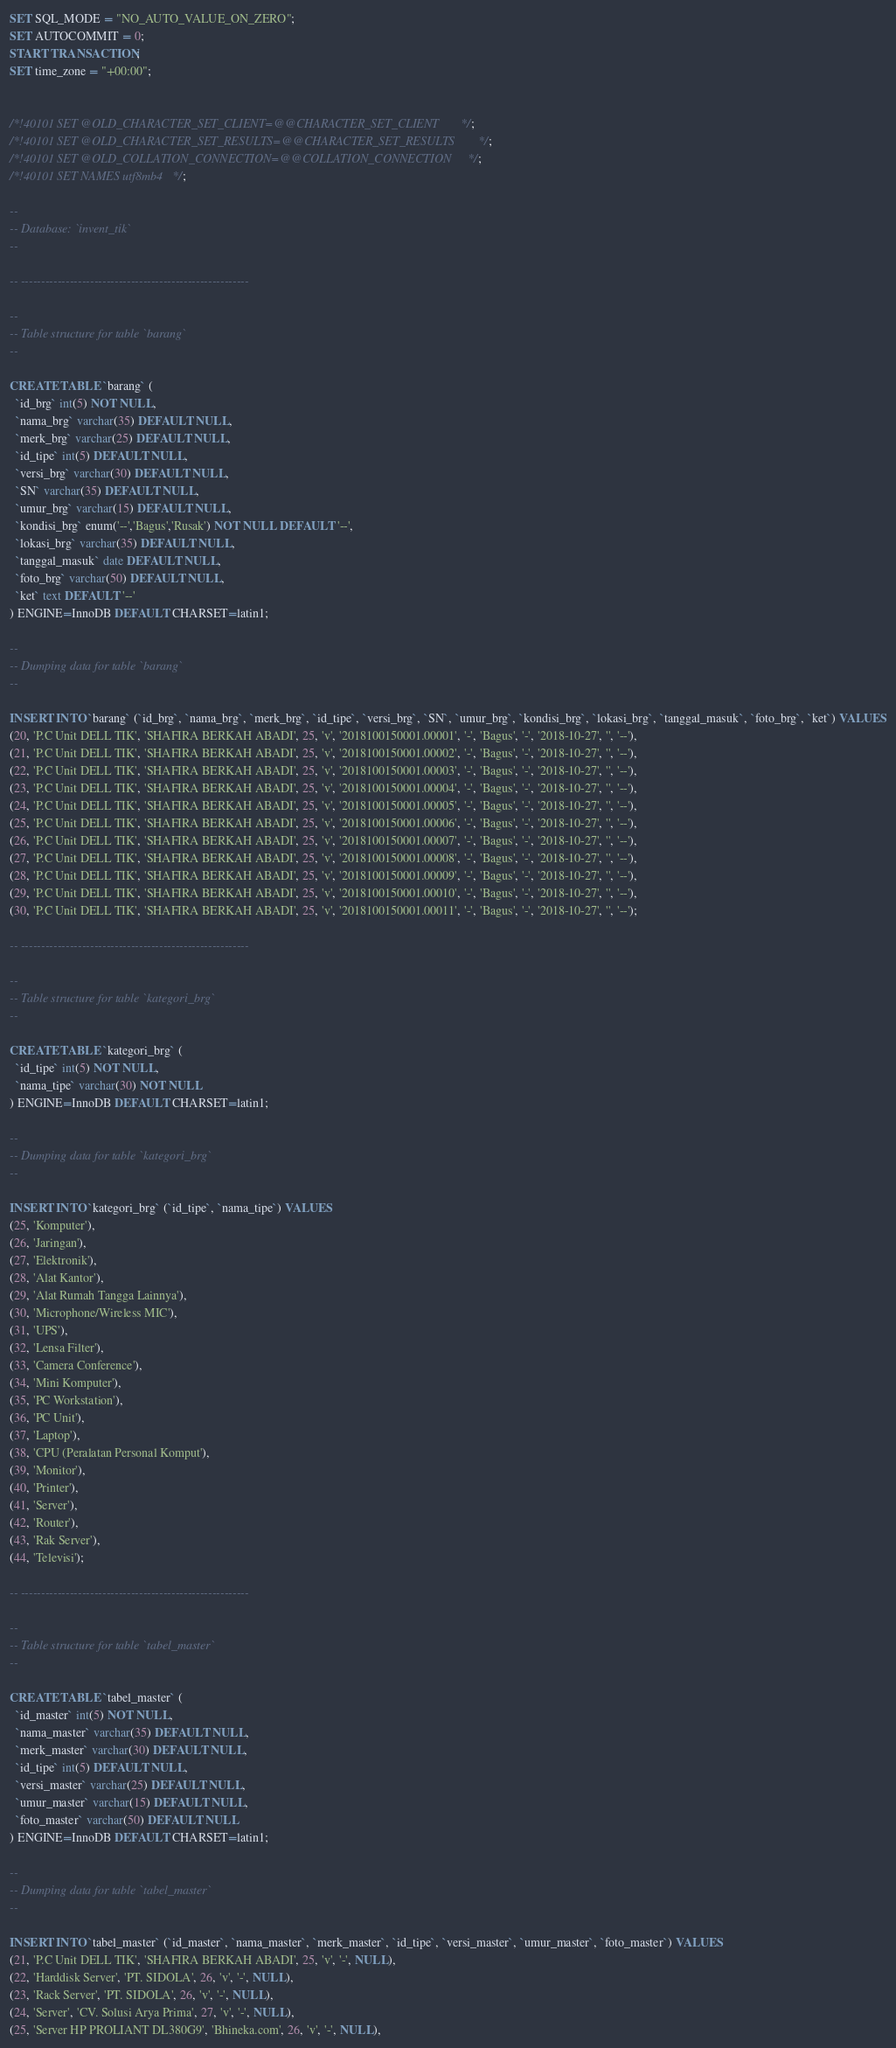Convert code to text. <code><loc_0><loc_0><loc_500><loc_500><_SQL_>SET SQL_MODE = "NO_AUTO_VALUE_ON_ZERO";
SET AUTOCOMMIT = 0;
START TRANSACTION;
SET time_zone = "+00:00";


/*!40101 SET @OLD_CHARACTER_SET_CLIENT=@@CHARACTER_SET_CLIENT */;
/*!40101 SET @OLD_CHARACTER_SET_RESULTS=@@CHARACTER_SET_RESULTS */;
/*!40101 SET @OLD_COLLATION_CONNECTION=@@COLLATION_CONNECTION */;
/*!40101 SET NAMES utf8mb4 */;

--
-- Database: `invent_tik`
--

-- --------------------------------------------------------

--
-- Table structure for table `barang`
--

CREATE TABLE `barang` (
  `id_brg` int(5) NOT NULL,
  `nama_brg` varchar(35) DEFAULT NULL,
  `merk_brg` varchar(25) DEFAULT NULL,
  `id_tipe` int(5) DEFAULT NULL,
  `versi_brg` varchar(30) DEFAULT NULL,
  `SN` varchar(35) DEFAULT NULL,
  `umur_brg` varchar(15) DEFAULT NULL,
  `kondisi_brg` enum('--','Bagus','Rusak') NOT NULL DEFAULT '--',
  `lokasi_brg` varchar(35) DEFAULT NULL,
  `tanggal_masuk` date DEFAULT NULL,
  `foto_brg` varchar(50) DEFAULT NULL,
  `ket` text DEFAULT '--'
) ENGINE=InnoDB DEFAULT CHARSET=latin1;

--
-- Dumping data for table `barang`
--

INSERT INTO `barang` (`id_brg`, `nama_brg`, `merk_brg`, `id_tipe`, `versi_brg`, `SN`, `umur_brg`, `kondisi_brg`, `lokasi_brg`, `tanggal_masuk`, `foto_brg`, `ket`) VALUES
(20, 'P.C Unit DELL TIK', 'SHAFIRA BERKAH ABADI', 25, 'v', '2018100150001.00001', '-', 'Bagus', '-', '2018-10-27', '', '--'),
(21, 'P.C Unit DELL TIK', 'SHAFIRA BERKAH ABADI', 25, 'v', '2018100150001.00002', '-', 'Bagus', '-', '2018-10-27', '', '--'),
(22, 'P.C Unit DELL TIK', 'SHAFIRA BERKAH ABADI', 25, 'v', '2018100150001.00003', '-', 'Bagus', '-', '2018-10-27', '', '--'),
(23, 'P.C Unit DELL TIK', 'SHAFIRA BERKAH ABADI', 25, 'v', '2018100150001.00004', '-', 'Bagus', '-', '2018-10-27', '', '--'),
(24, 'P.C Unit DELL TIK', 'SHAFIRA BERKAH ABADI', 25, 'v', '2018100150001.00005', '-', 'Bagus', '-', '2018-10-27', '', '--'),
(25, 'P.C Unit DELL TIK', 'SHAFIRA BERKAH ABADI', 25, 'v', '2018100150001.00006', '-', 'Bagus', '-', '2018-10-27', '', '--'),
(26, 'P.C Unit DELL TIK', 'SHAFIRA BERKAH ABADI', 25, 'v', '2018100150001.00007', '-', 'Bagus', '-', '2018-10-27', '', '--'),
(27, 'P.C Unit DELL TIK', 'SHAFIRA BERKAH ABADI', 25, 'v', '2018100150001.00008', '-', 'Bagus', '-', '2018-10-27', '', '--'),
(28, 'P.C Unit DELL TIK', 'SHAFIRA BERKAH ABADI', 25, 'v', '2018100150001.00009', '-', 'Bagus', '-', '2018-10-27', '', '--'),
(29, 'P.C Unit DELL TIK', 'SHAFIRA BERKAH ABADI', 25, 'v', '2018100150001.00010', '-', 'Bagus', '-', '2018-10-27', '', '--'),
(30, 'P.C Unit DELL TIK', 'SHAFIRA BERKAH ABADI', 25, 'v', '2018100150001.00011', '-', 'Bagus', '-', '2018-10-27', '', '--');

-- --------------------------------------------------------

--
-- Table structure for table `kategori_brg`
--

CREATE TABLE `kategori_brg` (
  `id_tipe` int(5) NOT NULL,
  `nama_tipe` varchar(30) NOT NULL
) ENGINE=InnoDB DEFAULT CHARSET=latin1;

--
-- Dumping data for table `kategori_brg`
--

INSERT INTO `kategori_brg` (`id_tipe`, `nama_tipe`) VALUES
(25, 'Komputer'),
(26, 'Jaringan'),
(27, 'Elektronik'),
(28, 'Alat Kantor'),
(29, 'Alat Rumah Tangga Lainnya'),
(30, 'Microphone/Wireless MIC'),
(31, 'UPS'),
(32, 'Lensa Filter'),
(33, 'Camera Conference'),
(34, 'Mini Komputer'),
(35, 'PC Workstation'),
(36, 'PC Unit'),
(37, 'Laptop'),
(38, 'CPU (Peralatan Personal Komput'),
(39, 'Monitor'),
(40, 'Printer'),
(41, 'Server'),
(42, 'Router'),
(43, 'Rak Server'),
(44, 'Televisi');

-- --------------------------------------------------------

--
-- Table structure for table `tabel_master`
--

CREATE TABLE `tabel_master` (
  `id_master` int(5) NOT NULL,
  `nama_master` varchar(35) DEFAULT NULL,
  `merk_master` varchar(30) DEFAULT NULL,
  `id_tipe` int(5) DEFAULT NULL,
  `versi_master` varchar(25) DEFAULT NULL,
  `umur_master` varchar(15) DEFAULT NULL,
  `foto_master` varchar(50) DEFAULT NULL
) ENGINE=InnoDB DEFAULT CHARSET=latin1;

--
-- Dumping data for table `tabel_master`
--

INSERT INTO `tabel_master` (`id_master`, `nama_master`, `merk_master`, `id_tipe`, `versi_master`, `umur_master`, `foto_master`) VALUES
(21, 'P.C Unit DELL TIK', 'SHAFIRA BERKAH ABADI', 25, 'v', '-', NULL),
(22, 'Harddisk Server', 'PT. SIDOLA', 26, 'v', '-', NULL),
(23, 'Rack Server', 'PT. SIDOLA', 26, 'v', '-', NULL),
(24, 'Server', 'CV. Solusi Arya Prima', 27, 'v', '-', NULL),
(25, 'Server HP PROLIANT DL380G9', 'Bhineka.com', 26, 'v', '-', NULL),</code> 